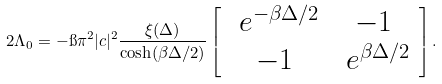Convert formula to latex. <formula><loc_0><loc_0><loc_500><loc_500>2 \Lambda _ { 0 } = - \i \pi ^ { 2 } | c | ^ { 2 } \frac { \xi ( \Delta ) } { \cosh ( \beta \Delta / 2 ) } \left [ \begin{array} { c c } \ e ^ { - \beta \Delta / 2 } & - 1 \\ - 1 & \ e ^ { \beta \Delta / 2 } \end{array} \right ] .</formula> 